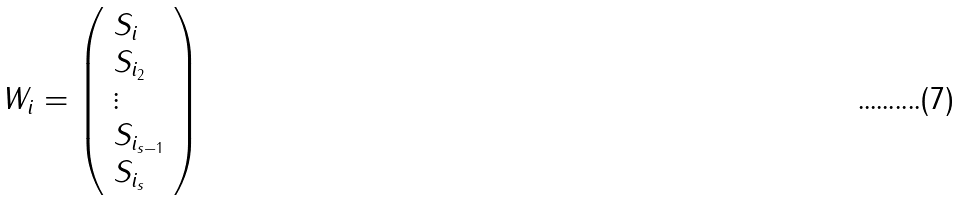Convert formula to latex. <formula><loc_0><loc_0><loc_500><loc_500>W _ { i } = \left ( \begin{array} { l } S _ { i } \\ S _ { i _ { 2 } } \\ \vdots \\ S _ { i _ { s - 1 } } \\ S _ { i _ { s } } \\ \end{array} \right )</formula> 